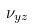Convert formula to latex. <formula><loc_0><loc_0><loc_500><loc_500>\nu _ { y z }</formula> 